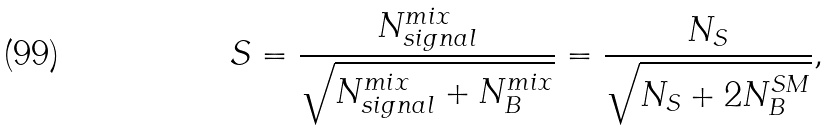Convert formula to latex. <formula><loc_0><loc_0><loc_500><loc_500>S = \frac { N ^ { m i x } _ { s i g n a l } } { \sqrt { N ^ { m i x } _ { s i g n a l } + N ^ { m i x } _ { B } } } = \frac { N _ { S } } { \sqrt { N _ { S } + 2 N ^ { S M } _ { B } } } ,</formula> 